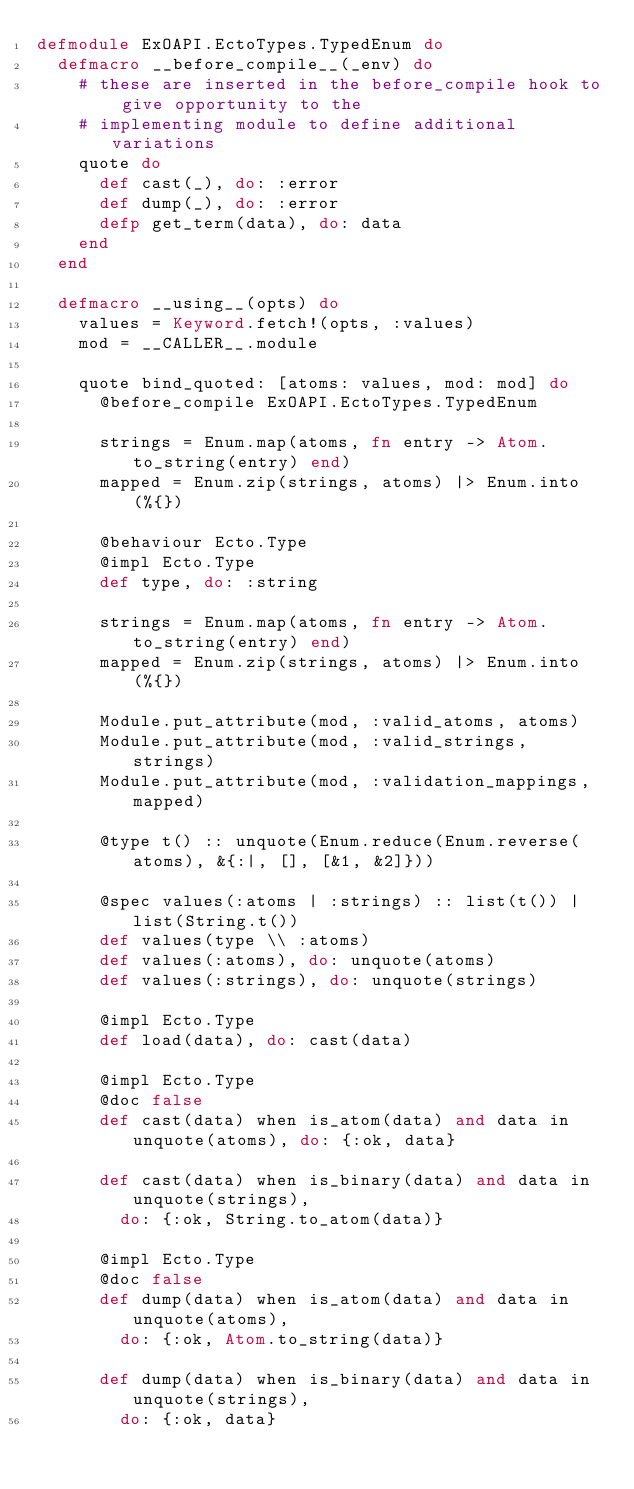Convert code to text. <code><loc_0><loc_0><loc_500><loc_500><_Elixir_>defmodule ExOAPI.EctoTypes.TypedEnum do
  defmacro __before_compile__(_env) do
    # these are inserted in the before_compile hook to give opportunity to the
    # implementing module to define additional variations
    quote do
      def cast(_), do: :error
      def dump(_), do: :error
      defp get_term(data), do: data
    end
  end

  defmacro __using__(opts) do
    values = Keyword.fetch!(opts, :values)
    mod = __CALLER__.module

    quote bind_quoted: [atoms: values, mod: mod] do
      @before_compile ExOAPI.EctoTypes.TypedEnum

      strings = Enum.map(atoms, fn entry -> Atom.to_string(entry) end)
      mapped = Enum.zip(strings, atoms) |> Enum.into(%{})

      @behaviour Ecto.Type
      @impl Ecto.Type
      def type, do: :string

      strings = Enum.map(atoms, fn entry -> Atom.to_string(entry) end)
      mapped = Enum.zip(strings, atoms) |> Enum.into(%{})

      Module.put_attribute(mod, :valid_atoms, atoms)
      Module.put_attribute(mod, :valid_strings, strings)
      Module.put_attribute(mod, :validation_mappings, mapped)

      @type t() :: unquote(Enum.reduce(Enum.reverse(atoms), &{:|, [], [&1, &2]}))

      @spec values(:atoms | :strings) :: list(t()) | list(String.t())
      def values(type \\ :atoms)
      def values(:atoms), do: unquote(atoms)
      def values(:strings), do: unquote(strings)

      @impl Ecto.Type
      def load(data), do: cast(data)

      @impl Ecto.Type
      @doc false
      def cast(data) when is_atom(data) and data in unquote(atoms), do: {:ok, data}

      def cast(data) when is_binary(data) and data in unquote(strings),
        do: {:ok, String.to_atom(data)}

      @impl Ecto.Type
      @doc false
      def dump(data) when is_atom(data) and data in unquote(atoms),
        do: {:ok, Atom.to_string(data)}

      def dump(data) when is_binary(data) and data in unquote(strings),
        do: {:ok, data}
</code> 